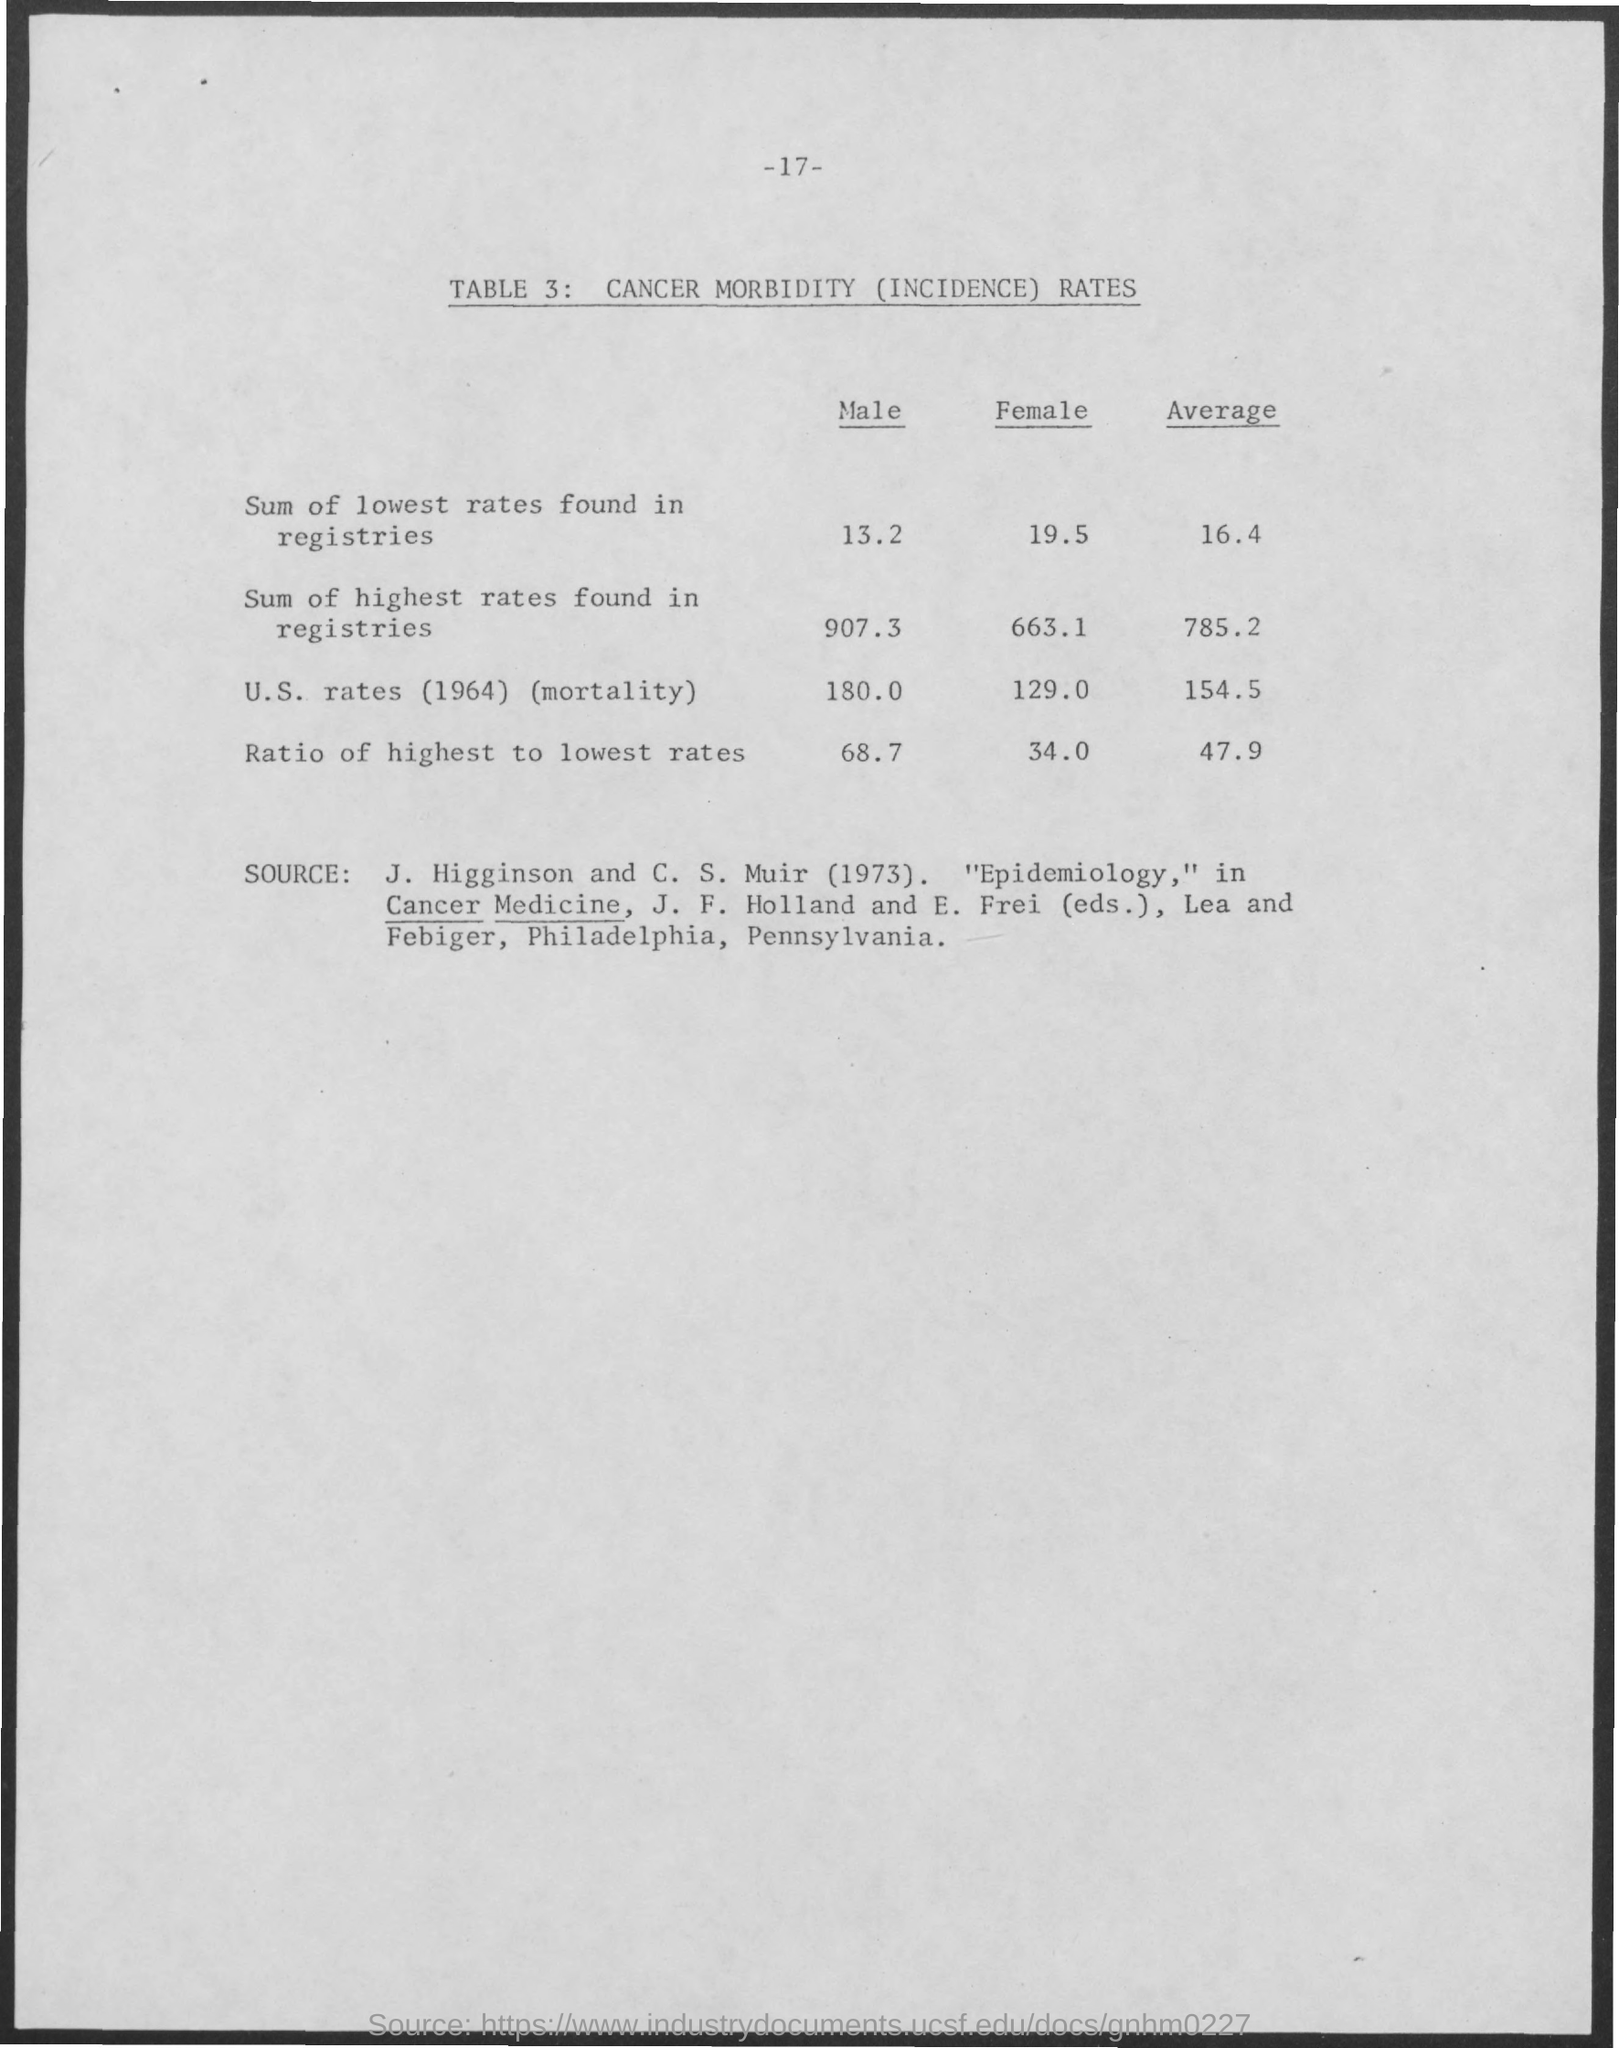Give some essential details in this illustration. The page number is 17. 